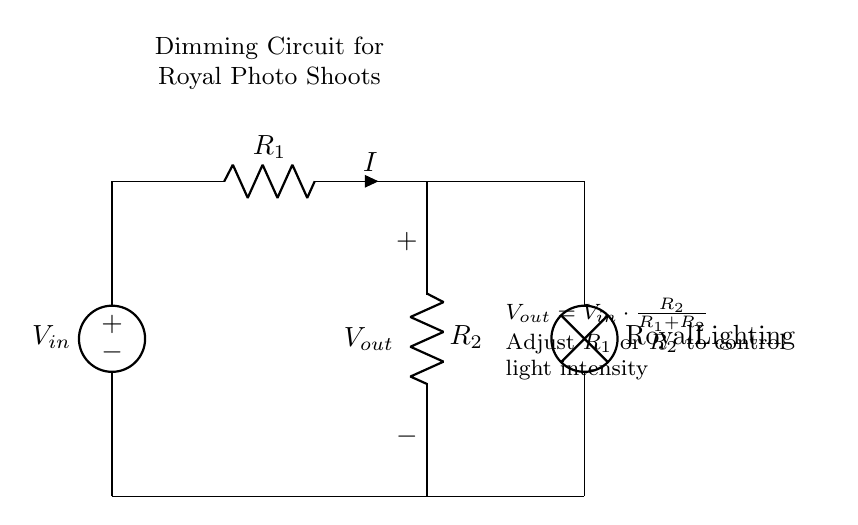What is the input voltage in this circuit? The input voltage in this circuit is labeled as V_in, which is the voltage supplied by the voltage source at the top of the diagram.
Answer: V_in What are R1 and R2 used for? R1 and R2 are resistors that create a voltage divider, allowing control over the output voltage V_out that determines the light intensity in the circuit.
Answer: Voltage divider What is the output voltage for equal resistors R1 and R2? If R1 and R2 are equal, the output voltage V_out will be half of the input voltage V_in. This can be derived from the voltage divider formula where V_out = V_in * (R2 / (R1 + R2)) and substituting R1 = R2.
Answer: V_in divided by 2 How can the lighting intensity be increased? The lighting intensity can be increased by decreasing R1 or increasing R2, as this adjusts the voltage divider ratio, leading to a higher V_out value.
Answer: Decrease R1 or increase R2 What is the purpose of the lamp in this circuit? The lamp is connected at V_out and serves as the load that receives the adjusted voltage to provide the desired lighting effect during photo shoots.
Answer: To provide lighting What happens to the current if R1 increases? If R1 increases, the overall resistance in the voltage divider increases, resulting in a decrease in current flowing through the circuit according to Ohm's law (I = V/R).
Answer: Decrease in current What design aspect allows for dimming control? The design aspect that allows for dimming control is the variable ratio of resistors R1 and R2 in the voltage divider, which directly affects the output voltage and thus the intensity of the light.
Answer: Resistor ratio adjustment 